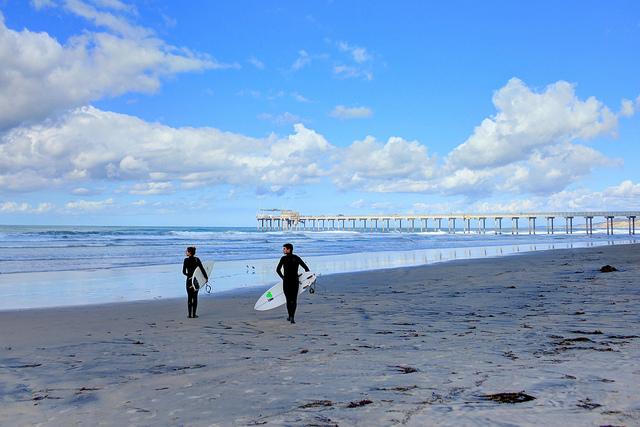What land feature is this?
Give a very brief answer. Beach. How many people are standing near the water?
Quick response, please. 2. Is the sky cloudy?
Short answer required. Yes. Is the man in the water?
Keep it brief. No. How many people are holding a surfboard?
Be succinct. 2. Why are these people wearing wetsuits?
Keep it brief. Surfing. How many cones are there?
Short answer required. 0. What sport are these people engaged in?
Keep it brief. Surfing. How many legs do the animals have?
Answer briefly. 2. 